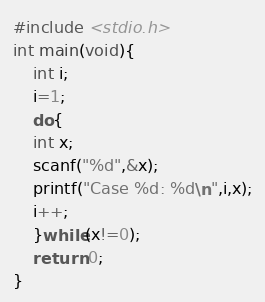Convert code to text. <code><loc_0><loc_0><loc_500><loc_500><_C_>#include <stdio.h>
int main(void){
    int i;
    i=1;
    do{
	int x;
	scanf("%d",&x);
	printf("Case %d: %d\n",i,x);
	i++;
    }while(x!=0);
    return 0;
}</code> 